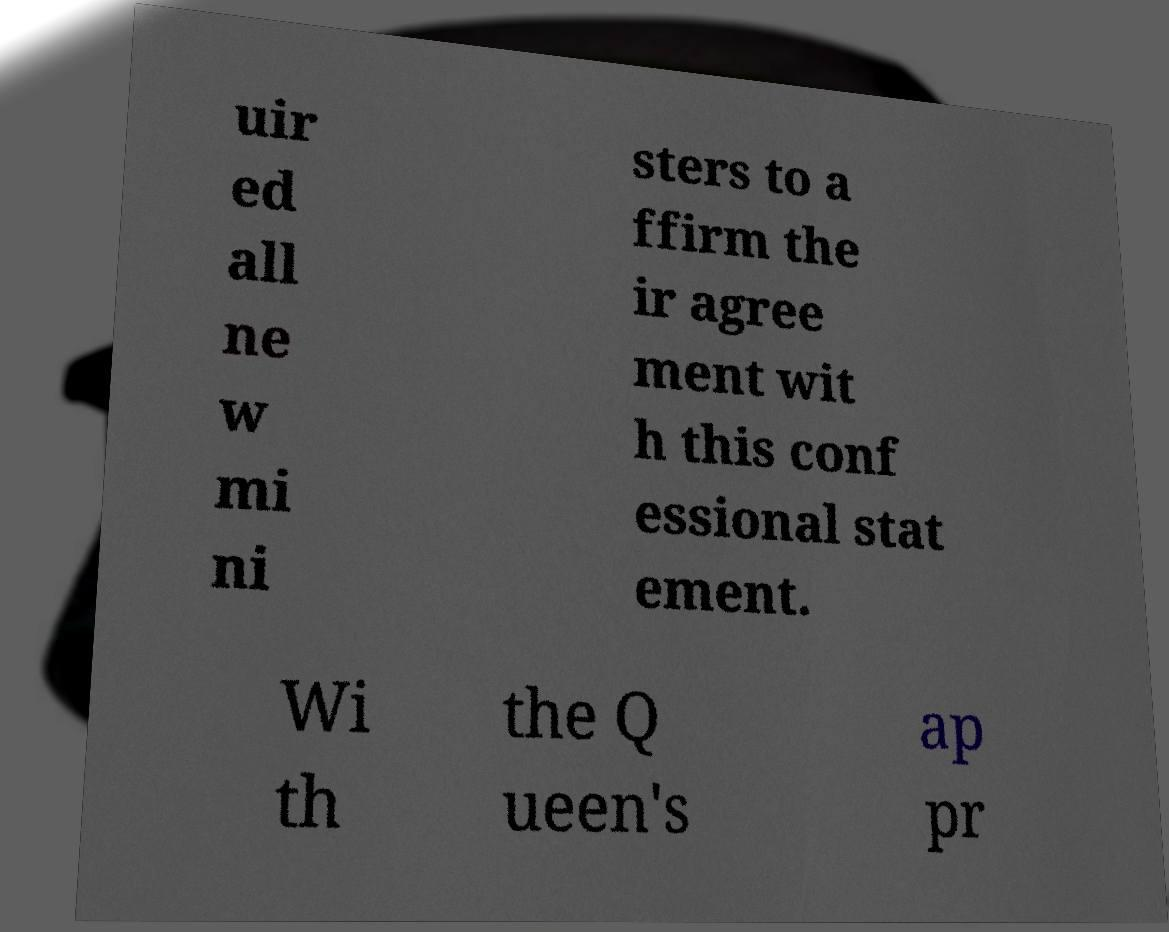Can you accurately transcribe the text from the provided image for me? uir ed all ne w mi ni sters to a ffirm the ir agree ment wit h this conf essional stat ement. Wi th the Q ueen's ap pr 